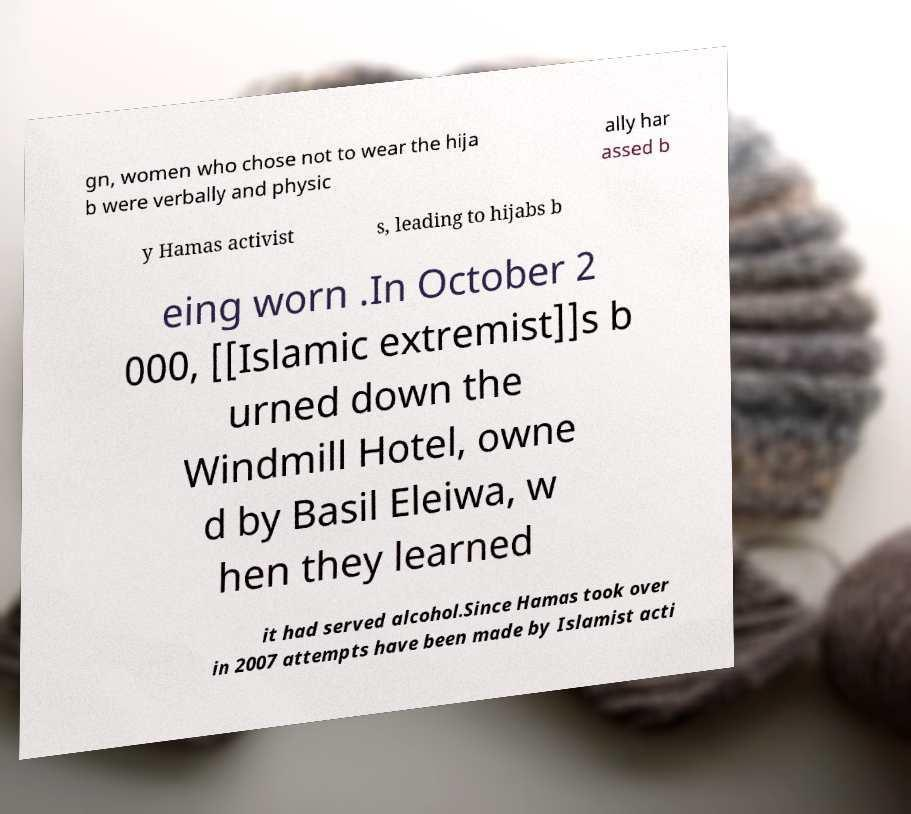For documentation purposes, I need the text within this image transcribed. Could you provide that? gn, women who chose not to wear the hija b were verbally and physic ally har assed b y Hamas activist s, leading to hijabs b eing worn .In October 2 000, [[Islamic extremist]]s b urned down the Windmill Hotel, owne d by Basil Eleiwa, w hen they learned it had served alcohol.Since Hamas took over in 2007 attempts have been made by Islamist acti 